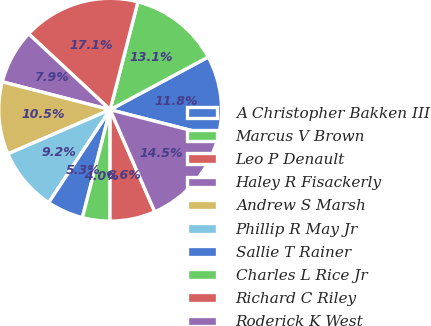Convert chart. <chart><loc_0><loc_0><loc_500><loc_500><pie_chart><fcel>A Christopher Bakken III<fcel>Marcus V Brown<fcel>Leo P Denault<fcel>Haley R Fisackerly<fcel>Andrew S Marsh<fcel>Phillip R May Jr<fcel>Sallie T Rainer<fcel>Charles L Rice Jr<fcel>Richard C Riley<fcel>Roderick K West<nl><fcel>11.83%<fcel>13.14%<fcel>17.07%<fcel>7.9%<fcel>10.52%<fcel>9.21%<fcel>5.29%<fcel>3.98%<fcel>6.59%<fcel>14.45%<nl></chart> 